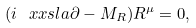Convert formula to latex. <formula><loc_0><loc_0><loc_500><loc_500>( i \ x x s l a { \partial } - M _ { R } ) R ^ { \mu } = 0 ,</formula> 